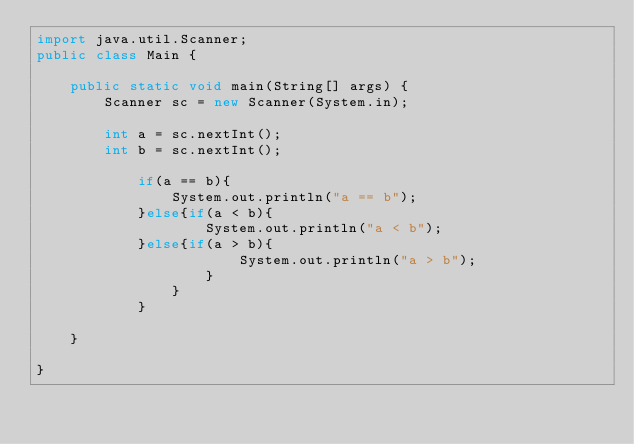Convert code to text. <code><loc_0><loc_0><loc_500><loc_500><_Java_>import java.util.Scanner;
public class Main {

	public static void main(String[] args) {
		Scanner sc = new Scanner(System.in);
		
		int a = sc.nextInt();
		int b = sc.nextInt();
		
			if(a == b){
				System.out.println("a == b");
			}else{if(a < b){
					System.out.println("a < b");
			}else{if(a > b){
						System.out.println("a > b");
					}
				}
			}

	}

}</code> 